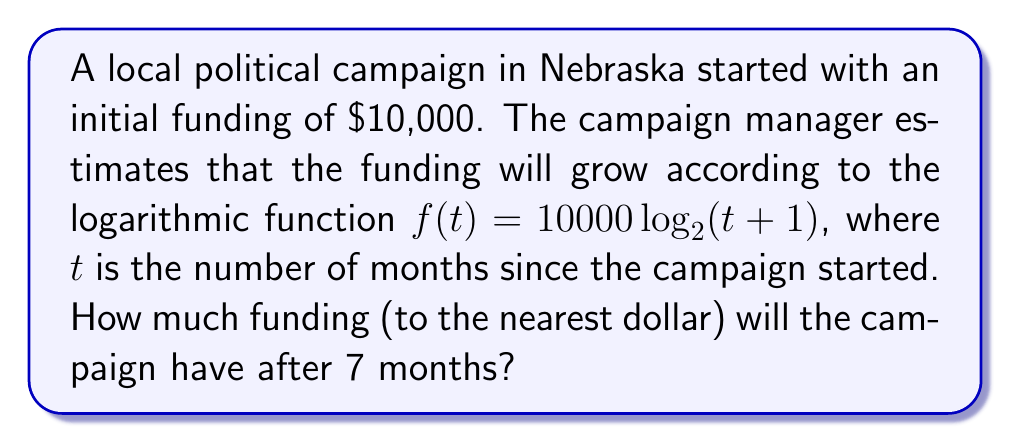Give your solution to this math problem. To solve this problem, we need to follow these steps:

1) We are given the logarithmic function: $f(t) = 10000 \log_2(t+1)$

2) We need to find $f(7)$, as we want to know the funding after 7 months:

   $f(7) = 10000 \log_2(7+1)$
   
   $f(7) = 10000 \log_2(8)$

3) Simplify $\log_2(8)$:
   
   $8 = 2^3$, so $\log_2(8) = 3$

4) Now we can calculate:

   $f(7) = 10000 \cdot 3 = 30000$

5) Therefore, after 7 months, the campaign will have $30,000 in funding.

This logarithmic growth model is often used in political campaigns to estimate funding growth, as it typically slows down over time but never stops completely, which is a realistic scenario for many local campaigns in Nebraska and elsewhere.
Answer: $30,000 